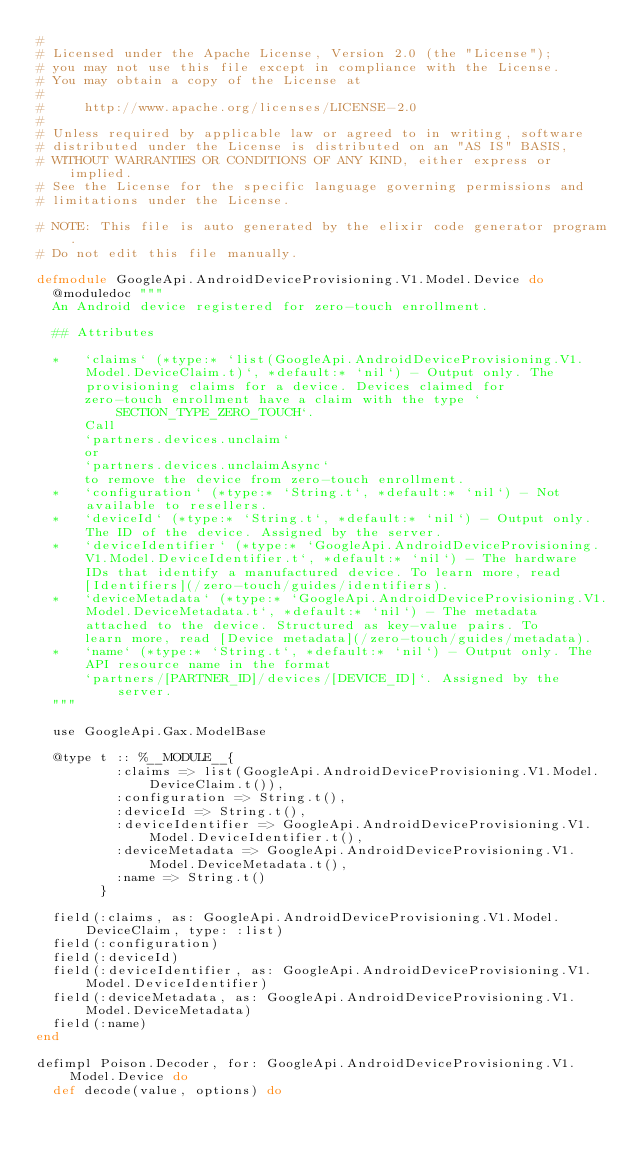<code> <loc_0><loc_0><loc_500><loc_500><_Elixir_>#
# Licensed under the Apache License, Version 2.0 (the "License");
# you may not use this file except in compliance with the License.
# You may obtain a copy of the License at
#
#     http://www.apache.org/licenses/LICENSE-2.0
#
# Unless required by applicable law or agreed to in writing, software
# distributed under the License is distributed on an "AS IS" BASIS,
# WITHOUT WARRANTIES OR CONDITIONS OF ANY KIND, either express or implied.
# See the License for the specific language governing permissions and
# limitations under the License.

# NOTE: This file is auto generated by the elixir code generator program.
# Do not edit this file manually.

defmodule GoogleApi.AndroidDeviceProvisioning.V1.Model.Device do
  @moduledoc """
  An Android device registered for zero-touch enrollment.

  ## Attributes

  *   `claims` (*type:* `list(GoogleApi.AndroidDeviceProvisioning.V1.Model.DeviceClaim.t)`, *default:* `nil`) - Output only. The provisioning claims for a device. Devices claimed for
      zero-touch enrollment have a claim with the type `SECTION_TYPE_ZERO_TOUCH`.
      Call
      `partners.devices.unclaim`
      or
      `partners.devices.unclaimAsync`
      to remove the device from zero-touch enrollment.
  *   `configuration` (*type:* `String.t`, *default:* `nil`) - Not available to resellers.
  *   `deviceId` (*type:* `String.t`, *default:* `nil`) - Output only. The ID of the device. Assigned by the server.
  *   `deviceIdentifier` (*type:* `GoogleApi.AndroidDeviceProvisioning.V1.Model.DeviceIdentifier.t`, *default:* `nil`) - The hardware IDs that identify a manufactured device. To learn more, read
      [Identifiers](/zero-touch/guides/identifiers).
  *   `deviceMetadata` (*type:* `GoogleApi.AndroidDeviceProvisioning.V1.Model.DeviceMetadata.t`, *default:* `nil`) - The metadata attached to the device. Structured as key-value pairs. To
      learn more, read [Device metadata](/zero-touch/guides/metadata).
  *   `name` (*type:* `String.t`, *default:* `nil`) - Output only. The API resource name in the format
      `partners/[PARTNER_ID]/devices/[DEVICE_ID]`. Assigned by the server.
  """

  use GoogleApi.Gax.ModelBase

  @type t :: %__MODULE__{
          :claims => list(GoogleApi.AndroidDeviceProvisioning.V1.Model.DeviceClaim.t()),
          :configuration => String.t(),
          :deviceId => String.t(),
          :deviceIdentifier => GoogleApi.AndroidDeviceProvisioning.V1.Model.DeviceIdentifier.t(),
          :deviceMetadata => GoogleApi.AndroidDeviceProvisioning.V1.Model.DeviceMetadata.t(),
          :name => String.t()
        }

  field(:claims, as: GoogleApi.AndroidDeviceProvisioning.V1.Model.DeviceClaim, type: :list)
  field(:configuration)
  field(:deviceId)
  field(:deviceIdentifier, as: GoogleApi.AndroidDeviceProvisioning.V1.Model.DeviceIdentifier)
  field(:deviceMetadata, as: GoogleApi.AndroidDeviceProvisioning.V1.Model.DeviceMetadata)
  field(:name)
end

defimpl Poison.Decoder, for: GoogleApi.AndroidDeviceProvisioning.V1.Model.Device do
  def decode(value, options) do</code> 